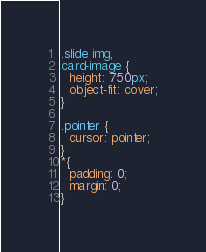<code> <loc_0><loc_0><loc_500><loc_500><_CSS_>.slide img,
card-image {
  height: 750px;
  object-fit: cover;
}

.pointer {
  cursor: pointer;
}
*{
  padding: 0;
  margin: 0;
}
</code> 